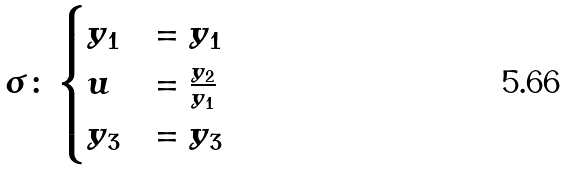<formula> <loc_0><loc_0><loc_500><loc_500>\sigma \colon \begin{cases} y _ { 1 } & = y _ { 1 } \\ u & = \frac { y _ { 2 } } { y _ { 1 } } \\ y _ { 3 } & = y _ { 3 } \end{cases}</formula> 